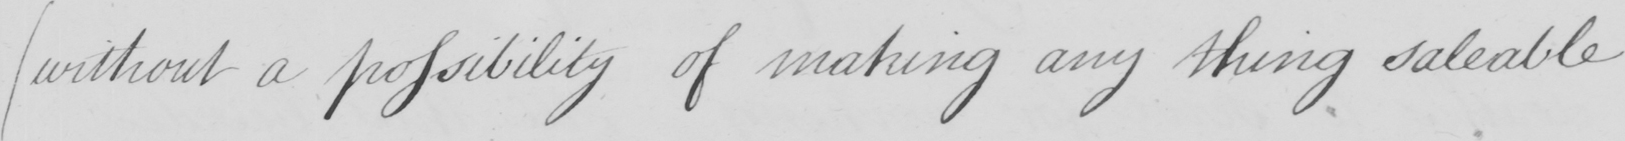Can you tell me what this handwritten text says? ( without a possibility of making any thing saleable 